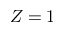<formula> <loc_0><loc_0><loc_500><loc_500>Z = 1</formula> 